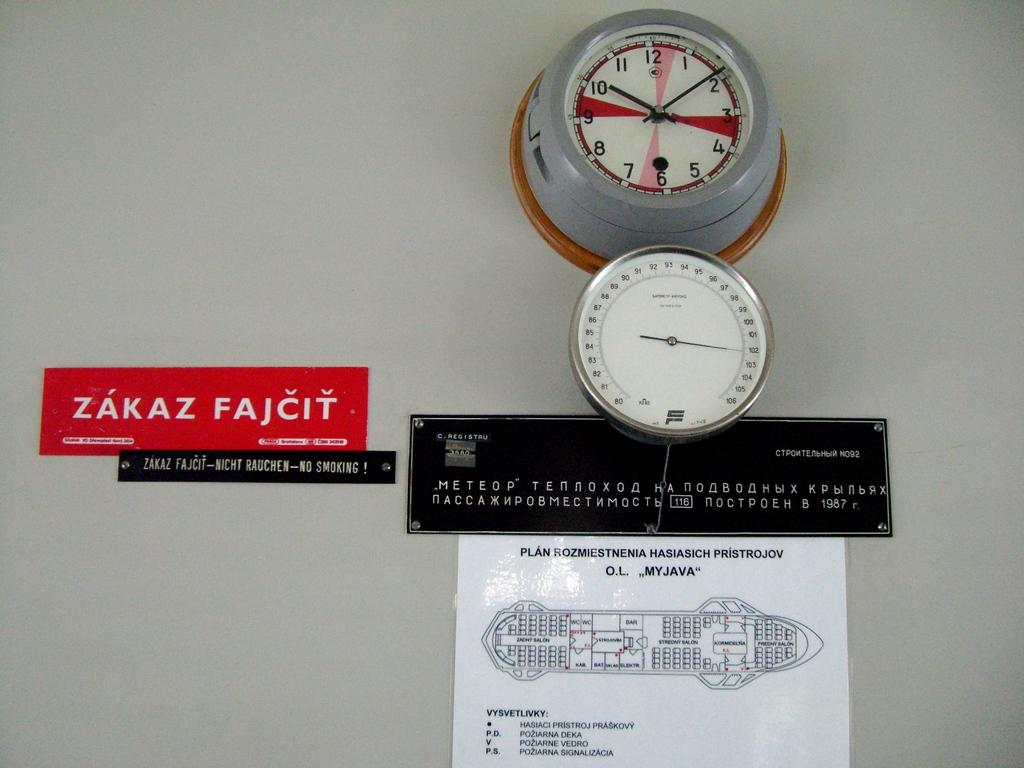What type of timekeeping device is present in the image? There is a wall clock in the image. What information can be seen related to energy or utilities in the image? There are meter readings in the image. What type of object is attached to the wall in the image? There are boards on the wall in the image. What type of shirt is the lawyer wearing in the image? There is no shirt, lawyer, or any person present in the image. The image only contains a wall clock, meter readings, and boards on the wall. 